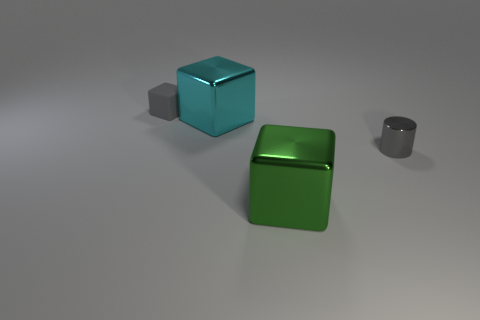Add 1 big cyan cubes. How many objects exist? 5 Subtract all blocks. How many objects are left? 1 Subtract 0 brown balls. How many objects are left? 4 Subtract all purple cylinders. Subtract all tiny metal cylinders. How many objects are left? 3 Add 1 big green objects. How many big green objects are left? 2 Add 4 cyan shiny blocks. How many cyan shiny blocks exist? 5 